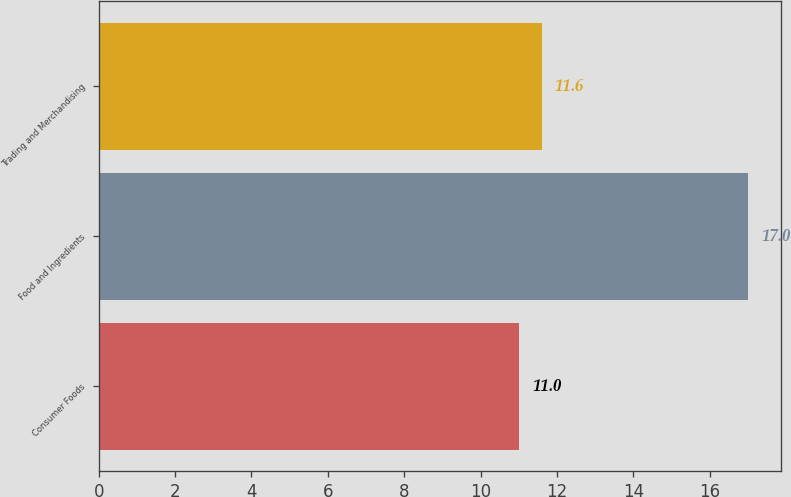Convert chart. <chart><loc_0><loc_0><loc_500><loc_500><bar_chart><fcel>Consumer Foods<fcel>Food and Ingredients<fcel>Trading and Merchandising<nl><fcel>11<fcel>17<fcel>11.6<nl></chart> 